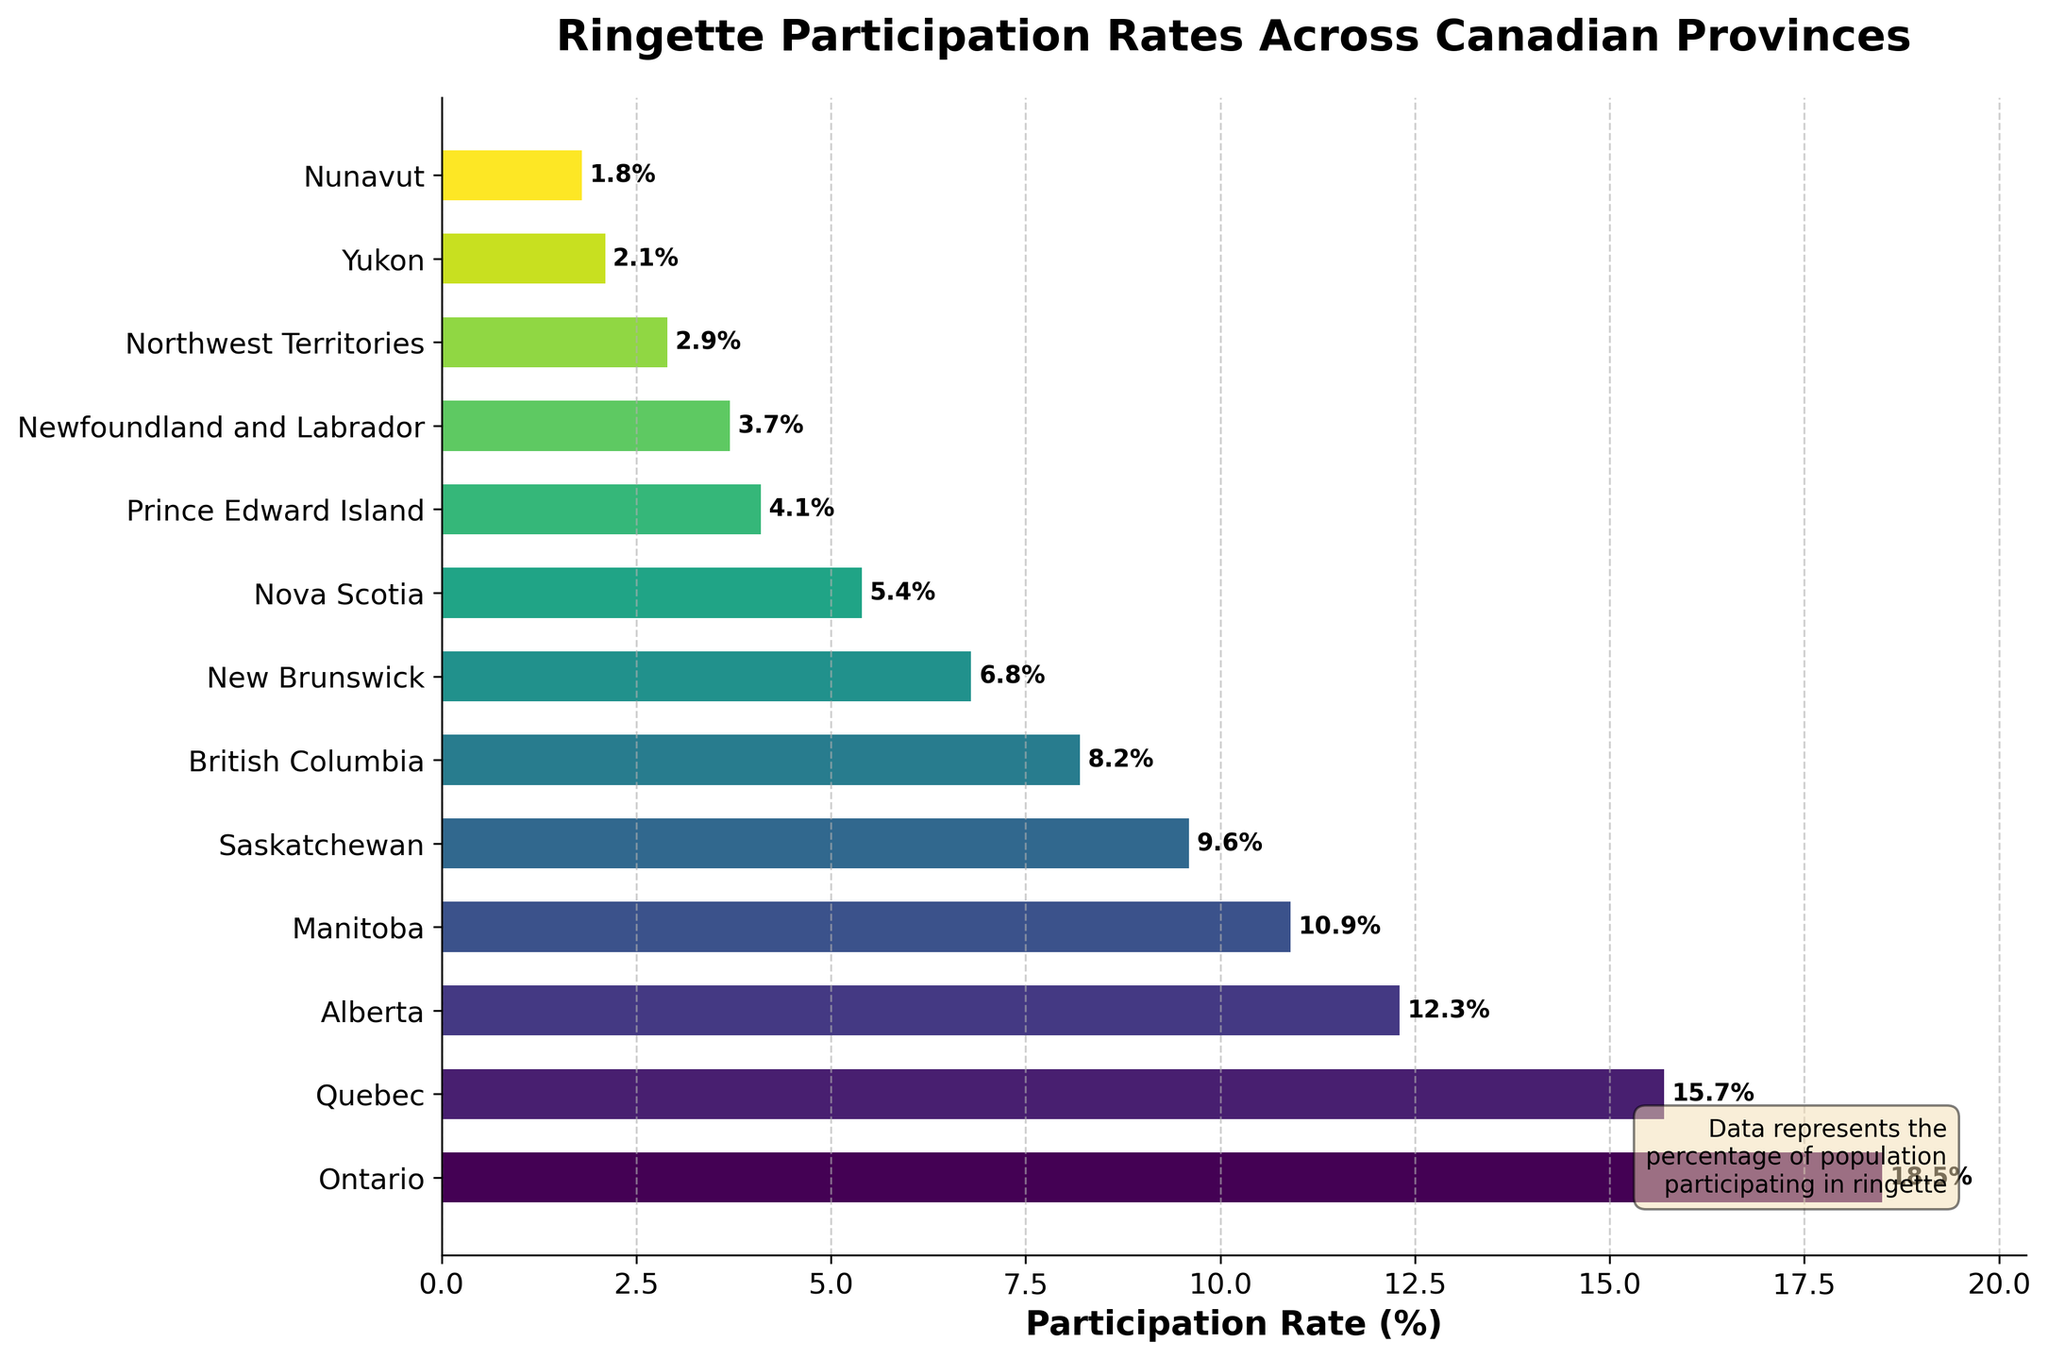What's the province with the highest participation rate in ringette? The bar with the longest length represents the province with the highest participation rate. Here, Ontario has the highest participation rate of 18.5%.
Answer: Ontario Which province has the lowest participation rate, and what's the percentage? The shortest bar in the chart corresponds to the province with the lowest participation rate. Nunavut has the lowest rate at 1.8%.
Answer: Nunavut, 1.8% How much higher is the participation rate in Ontario compared to Quebec? Ontario's participation rate is 18.5%, and Quebec's is 15.7%. The difference is calculated as 18.5% - 15.7% = 2.8%.
Answer: 2.8% What's the total participation rate of the three provinces with the highest values? The top three provinces by participation rate are Ontario (18.5%), Quebec (15.7%), and Alberta (12.3%). The sum is 18.5% + 15.7% + 12.3% = 46.5%.
Answer: 46.5% Which province has a higher participation rate, Manitoba or Saskatchewan, and by how much? Manitoba's participation rate is 10.9%, and Saskatchewan's is 9.6%. The difference is calculated as 10.9% - 9.6% = 1.3%.
Answer: Manitoba, 1.3% What's the average participation rate across all provinces and territories? Add all participation rates and divide by the number of provinces and territories. The sum is 100.0%. There are 13 provinces and territories, so the average is 100.0% / 13 ≈ 7.69%.
Answer: 7.69% Between British Columbia and New Brunswick, which has a lower participation rate and by how much? British Columbia's participation rate is 8.2%, and New Brunswick's is 6.8%. The difference is 8.2% - 6.8% = 1.4%.
Answer: New Brunswick, 1.4% What is the combined participation rate of all Atlantic provinces (New Brunswick, Nova Scotia, Prince Edward Island, and Newfoundland and Labrador)? The participation rates are New Brunswick (6.8%), Nova Scotia (5.4%), Prince Edward Island (4.1%), and Newfoundland and Labrador (3.7%). Summing them up: 6.8% + 5.4% + 4.1% + 3.7% = 20%.
Answer: 20% Is the participation rate of Alberta greater than the average participation rate? Alberta's rate is 12.3%. The average rate is approximately 7.69%. Since 12.3% > 7.69%, Alberta's participation rate is indeed greater than the average.
Answer: Yes Which provinces have participation rates below the average rate of 7.69%? Check each province's rate against the 7.69% average. The provinces below the average are British Columbia (8.2%), New Brunswick (6.8%), Nova Scotia (5.4%), Prince Edward Island (4.1%), Newfoundland and Labrador (3.7%), Northwest Territories (2.9%), Yukon (2.1%), and Nunavut (1.8%).
Answer: British Columbia, New Brunswick, Nova Scotia, Prince Edward Island, Newfoundland and Labrador, Northwest Territories, Yukon, Nunavut 